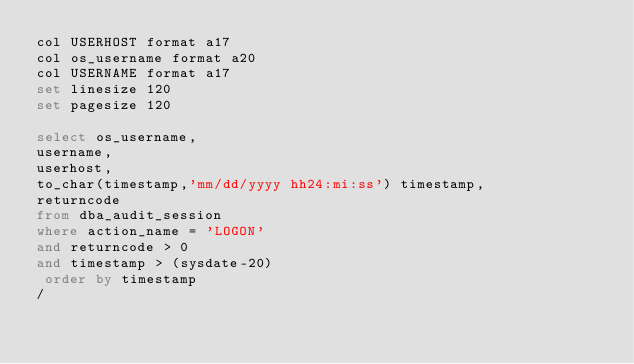<code> <loc_0><loc_0><loc_500><loc_500><_SQL_>col USERHOST format a17
col os_username format a20
col USERNAME format a17
set linesize 120
set pagesize 120

select os_username,
username,
userhost,
to_char(timestamp,'mm/dd/yyyy hh24:mi:ss') timestamp,
returncode
from dba_audit_session
where action_name = 'LOGON'
and returncode > 0
and timestamp > (sysdate-20)
 order by timestamp
/

</code> 